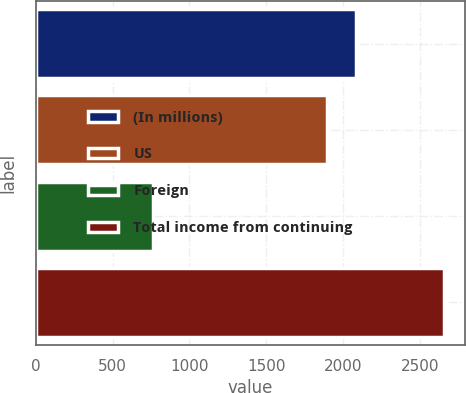Convert chart. <chart><loc_0><loc_0><loc_500><loc_500><bar_chart><fcel>(In millions)<fcel>US<fcel>Foreign<fcel>Total income from continuing<nl><fcel>2082.3<fcel>1893<fcel>764<fcel>2657<nl></chart> 